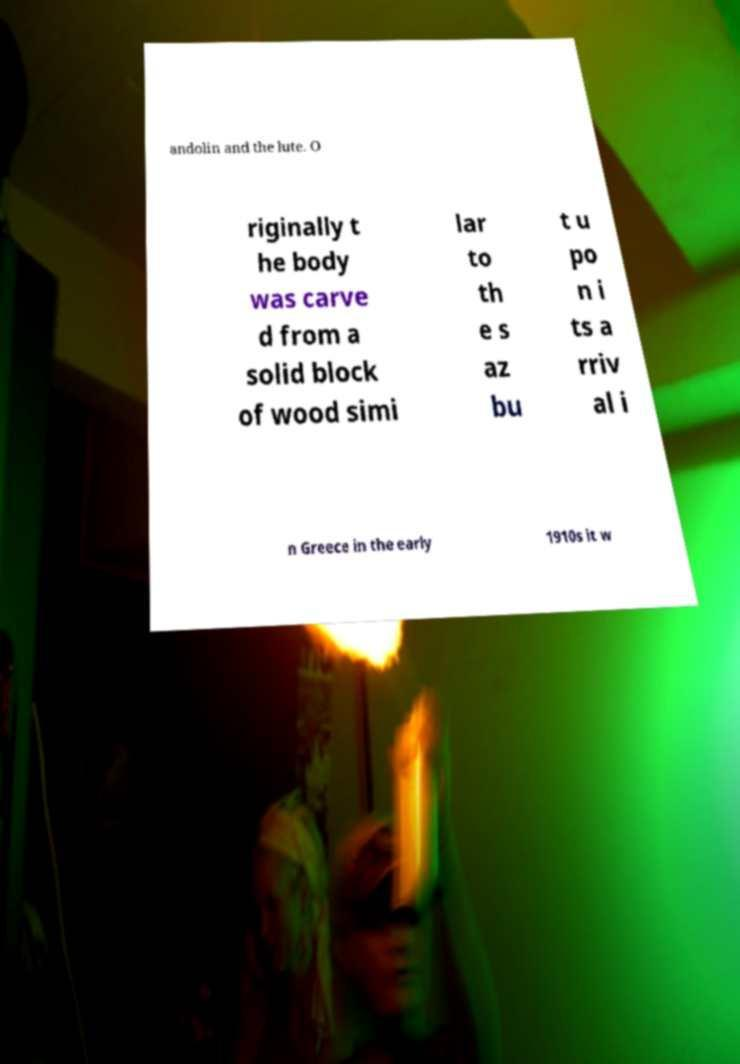Please read and relay the text visible in this image. What does it say? andolin and the lute. O riginally t he body was carve d from a solid block of wood simi lar to th e s az bu t u po n i ts a rriv al i n Greece in the early 1910s it w 